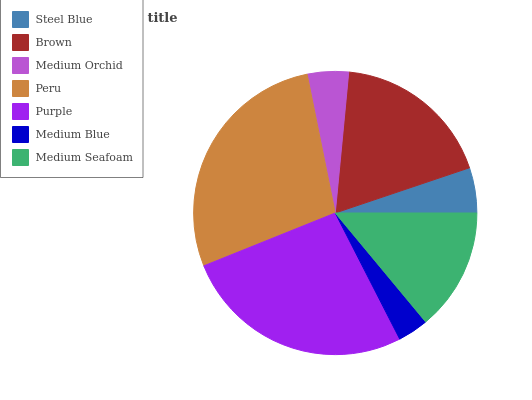Is Medium Blue the minimum?
Answer yes or no. Yes. Is Peru the maximum?
Answer yes or no. Yes. Is Brown the minimum?
Answer yes or no. No. Is Brown the maximum?
Answer yes or no. No. Is Brown greater than Steel Blue?
Answer yes or no. Yes. Is Steel Blue less than Brown?
Answer yes or no. Yes. Is Steel Blue greater than Brown?
Answer yes or no. No. Is Brown less than Steel Blue?
Answer yes or no. No. Is Medium Seafoam the high median?
Answer yes or no. Yes. Is Medium Seafoam the low median?
Answer yes or no. Yes. Is Steel Blue the high median?
Answer yes or no. No. Is Brown the low median?
Answer yes or no. No. 